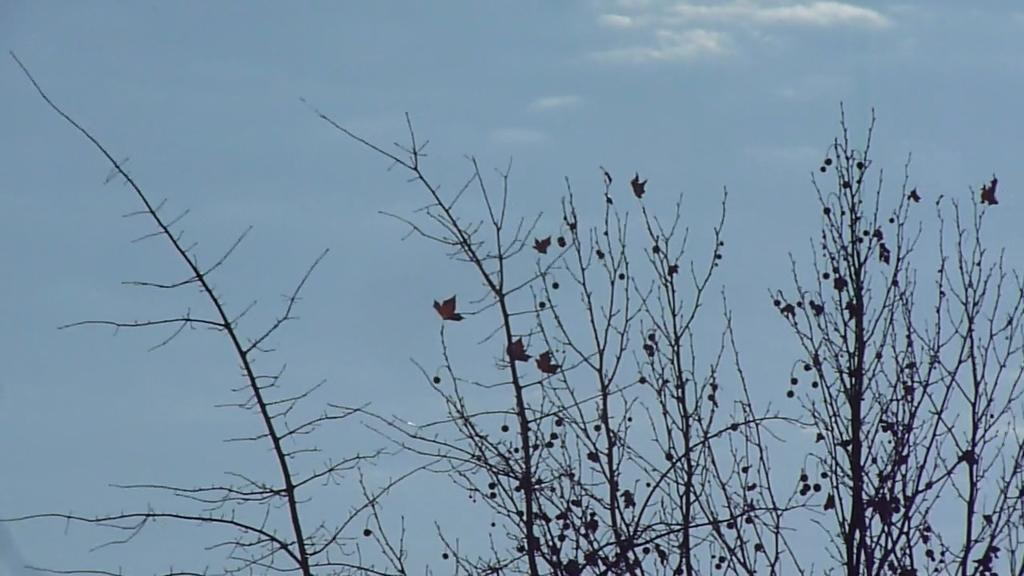What type of tree is depicted in the image? There is a dried tree in the image. What is the condition of the leaves on the tree? The dried tree has dried leaves. Are there any additional objects on the tree? Yes, there are other objects on the dried tree. How many bikes are hanging from the dried tree in the image? There are no bikes present in the image; it only features a dried tree with dried leaves and other objects. Can you see any feet on the dried tree in the image? There are no feet visible on the dried tree in the image. 